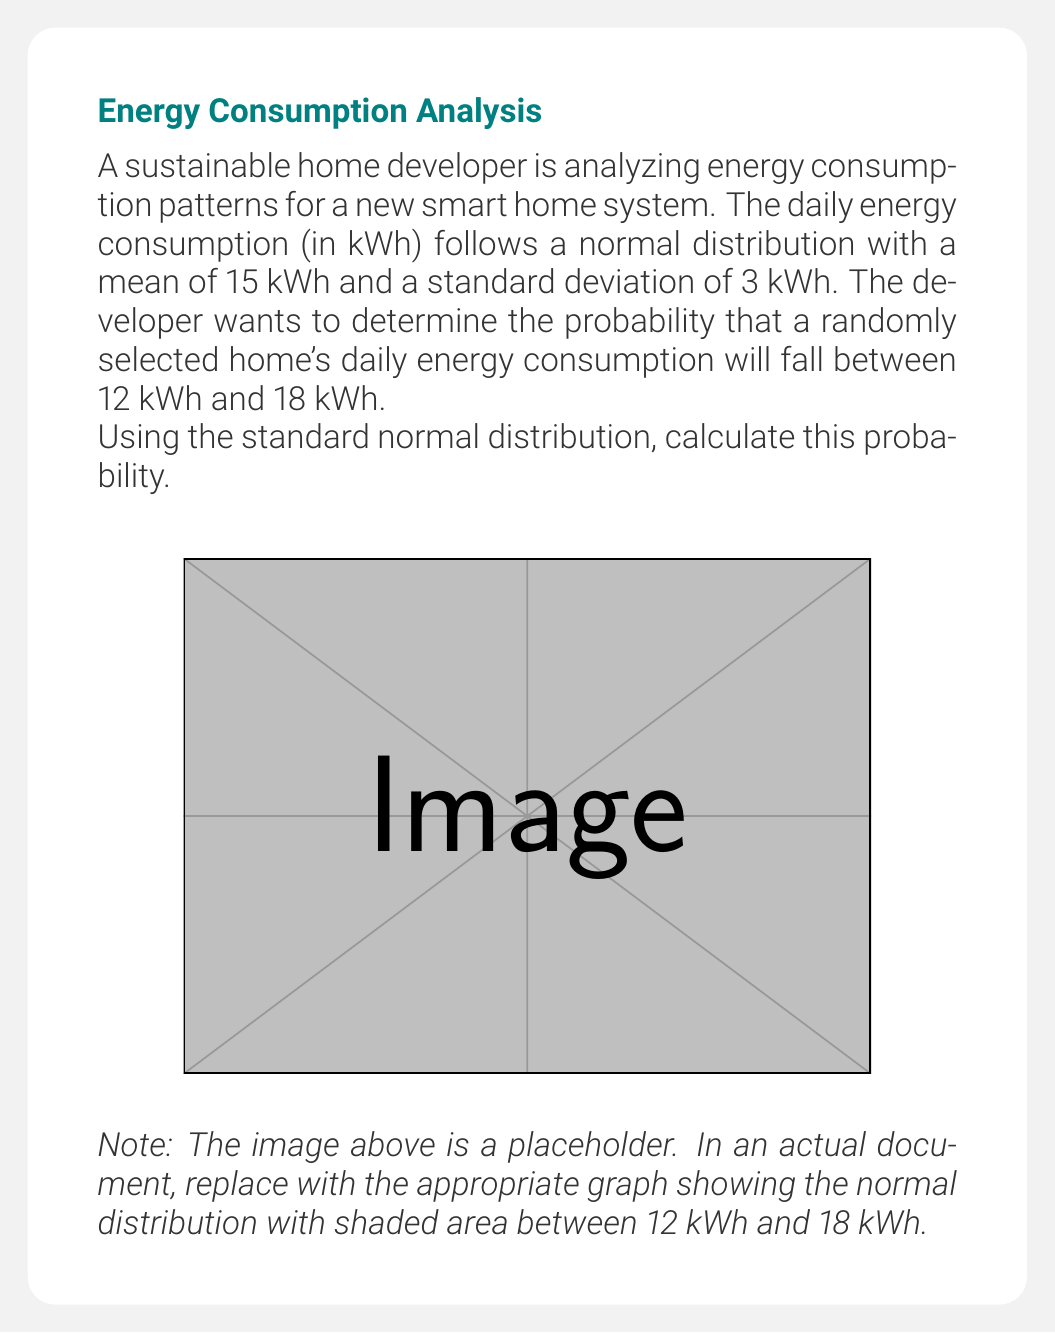Give your solution to this math problem. To solve this problem, we'll follow these steps:

1) First, we need to standardize the given values. The z-score formula is:

   $$ z = \frac{x - \mu}{\sigma} $$

   where $x$ is the value, $\mu$ is the mean, and $\sigma$ is the standard deviation.

2) For the lower bound (12 kWh):
   $$ z_1 = \frac{12 - 15}{3} = -1 $$

3) For the upper bound (18 kWh):
   $$ z_2 = \frac{18 - 15}{3} = 1 $$

4) Now, we need to find the area under the standard normal curve between z = -1 and z = 1.

5) Using a standard normal distribution table or calculator:
   $P(Z \leq 1) = 0.8413$
   $P(Z \leq -1) = 0.1587$

6) The probability we're looking for is the difference between these two:
   $P(-1 \leq Z \leq 1) = 0.8413 - 0.1587 = 0.6826$

Therefore, the probability that a randomly selected home's daily energy consumption will fall between 12 kWh and 18 kWh is approximately 0.6826 or 68.26%.
Answer: 0.6826 (or 68.26%) 